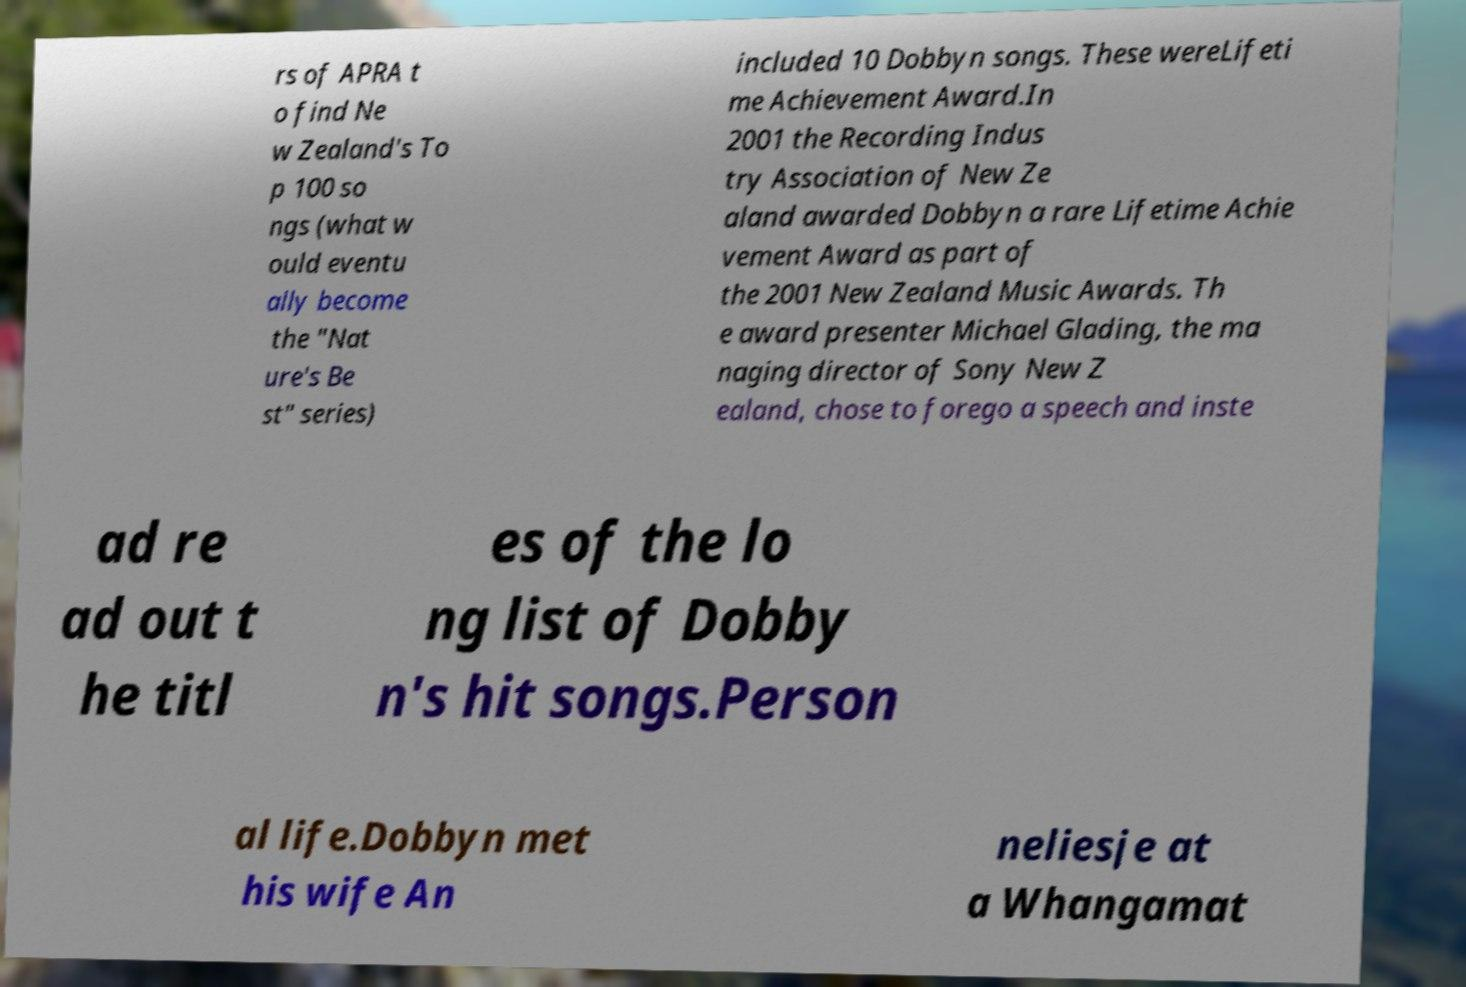Please identify and transcribe the text found in this image. rs of APRA t o find Ne w Zealand's To p 100 so ngs (what w ould eventu ally become the "Nat ure's Be st" series) included 10 Dobbyn songs. These wereLifeti me Achievement Award.In 2001 the Recording Indus try Association of New Ze aland awarded Dobbyn a rare Lifetime Achie vement Award as part of the 2001 New Zealand Music Awards. Th e award presenter Michael Glading, the ma naging director of Sony New Z ealand, chose to forego a speech and inste ad re ad out t he titl es of the lo ng list of Dobby n's hit songs.Person al life.Dobbyn met his wife An neliesje at a Whangamat 